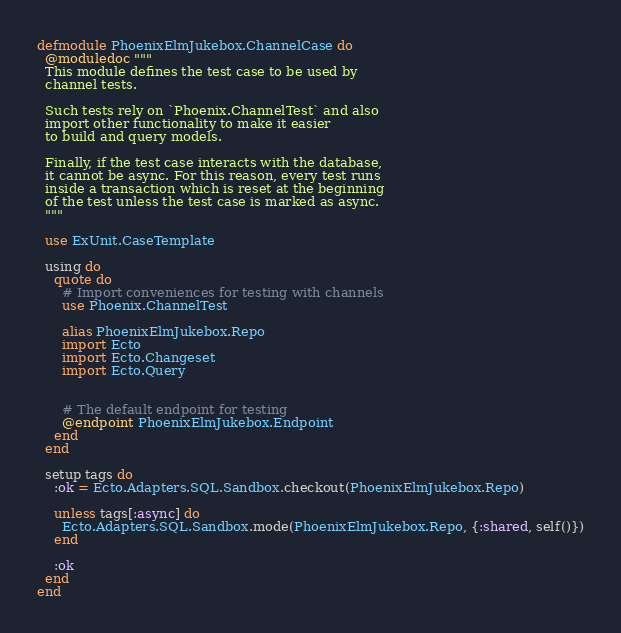Convert code to text. <code><loc_0><loc_0><loc_500><loc_500><_Elixir_>defmodule PhoenixElmJukebox.ChannelCase do
  @moduledoc """
  This module defines the test case to be used by
  channel tests.

  Such tests rely on `Phoenix.ChannelTest` and also
  import other functionality to make it easier
  to build and query models.

  Finally, if the test case interacts with the database,
  it cannot be async. For this reason, every test runs
  inside a transaction which is reset at the beginning
  of the test unless the test case is marked as async.
  """

  use ExUnit.CaseTemplate

  using do
    quote do
      # Import conveniences for testing with channels
      use Phoenix.ChannelTest

      alias PhoenixElmJukebox.Repo
      import Ecto
      import Ecto.Changeset
      import Ecto.Query


      # The default endpoint for testing
      @endpoint PhoenixElmJukebox.Endpoint
    end
  end

  setup tags do
    :ok = Ecto.Adapters.SQL.Sandbox.checkout(PhoenixElmJukebox.Repo)

    unless tags[:async] do
      Ecto.Adapters.SQL.Sandbox.mode(PhoenixElmJukebox.Repo, {:shared, self()})
    end

    :ok
  end
end
</code> 